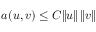<formula> <loc_0><loc_0><loc_500><loc_500>a ( u , v ) \leq C \| u \| \, \| v \|</formula> 